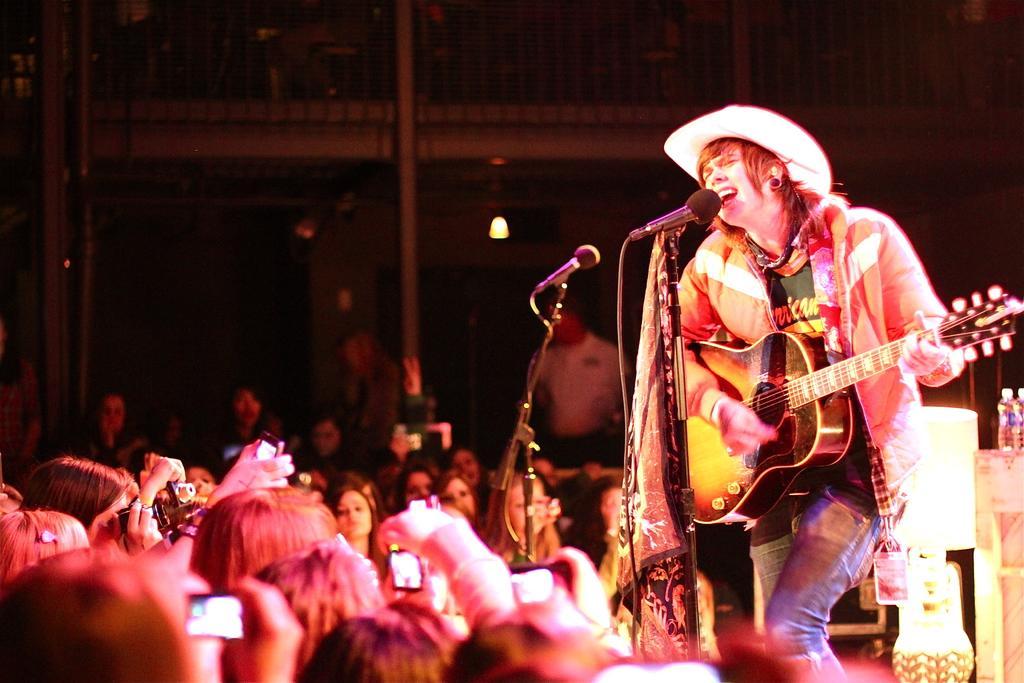Can you describe this image briefly? In this image there is a person standing on a stage, he is playing guitar and singing. There is a bottle on the table behind the person, there is a microphone in-front of the person and there are many audience standing and holding a phone. It seems to be a music concert. 